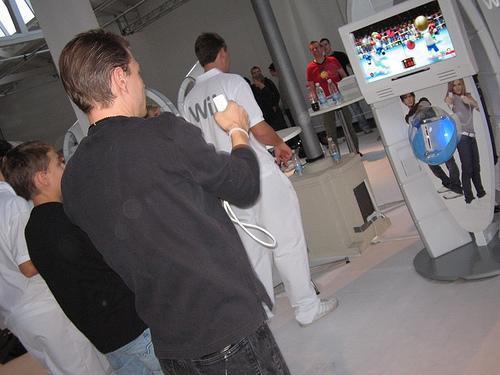How many people are there?
Give a very brief answer. 4. 